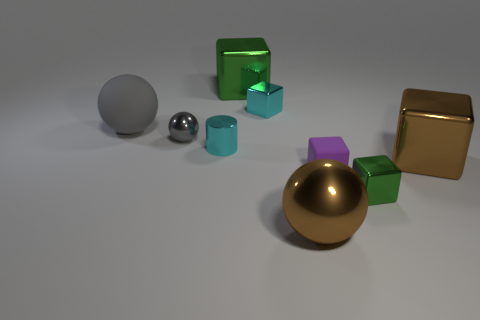How many big things are either gray rubber things or metallic blocks? In the image, there are two large gray rubber spheres and one large metallic gold cube. Therefore, the total count of big items that are gray rubber objects or metallic blocks is three. 